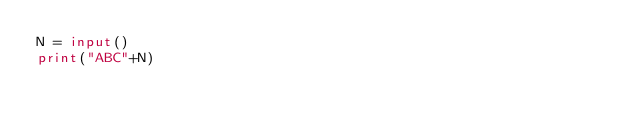<code> <loc_0><loc_0><loc_500><loc_500><_Python_>N = input()
print("ABC"+N)
</code> 